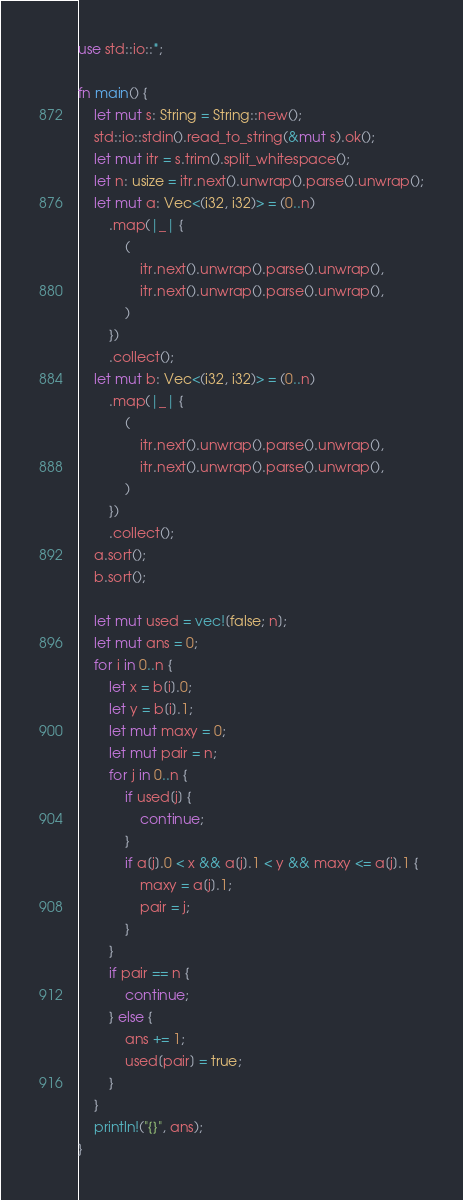Convert code to text. <code><loc_0><loc_0><loc_500><loc_500><_Rust_>use std::io::*;

fn main() {
    let mut s: String = String::new();
    std::io::stdin().read_to_string(&mut s).ok();
    let mut itr = s.trim().split_whitespace();
    let n: usize = itr.next().unwrap().parse().unwrap();
    let mut a: Vec<(i32, i32)> = (0..n)
        .map(|_| {
            (
                itr.next().unwrap().parse().unwrap(),
                itr.next().unwrap().parse().unwrap(),
            )
        })
        .collect();
    let mut b: Vec<(i32, i32)> = (0..n)
        .map(|_| {
            (
                itr.next().unwrap().parse().unwrap(),
                itr.next().unwrap().parse().unwrap(),
            )
        })
        .collect();
    a.sort();
    b.sort();

    let mut used = vec![false; n];
    let mut ans = 0;
    for i in 0..n {
        let x = b[i].0;
        let y = b[i].1;
        let mut maxy = 0;
        let mut pair = n;
        for j in 0..n {
            if used[j] {
                continue;
            }
            if a[j].0 < x && a[j].1 < y && maxy <= a[j].1 {
                maxy = a[j].1;
                pair = j;
            }
        }
        if pair == n {
            continue;
        } else {
            ans += 1;
            used[pair] = true;
        }
    }
    println!("{}", ans);
}
</code> 